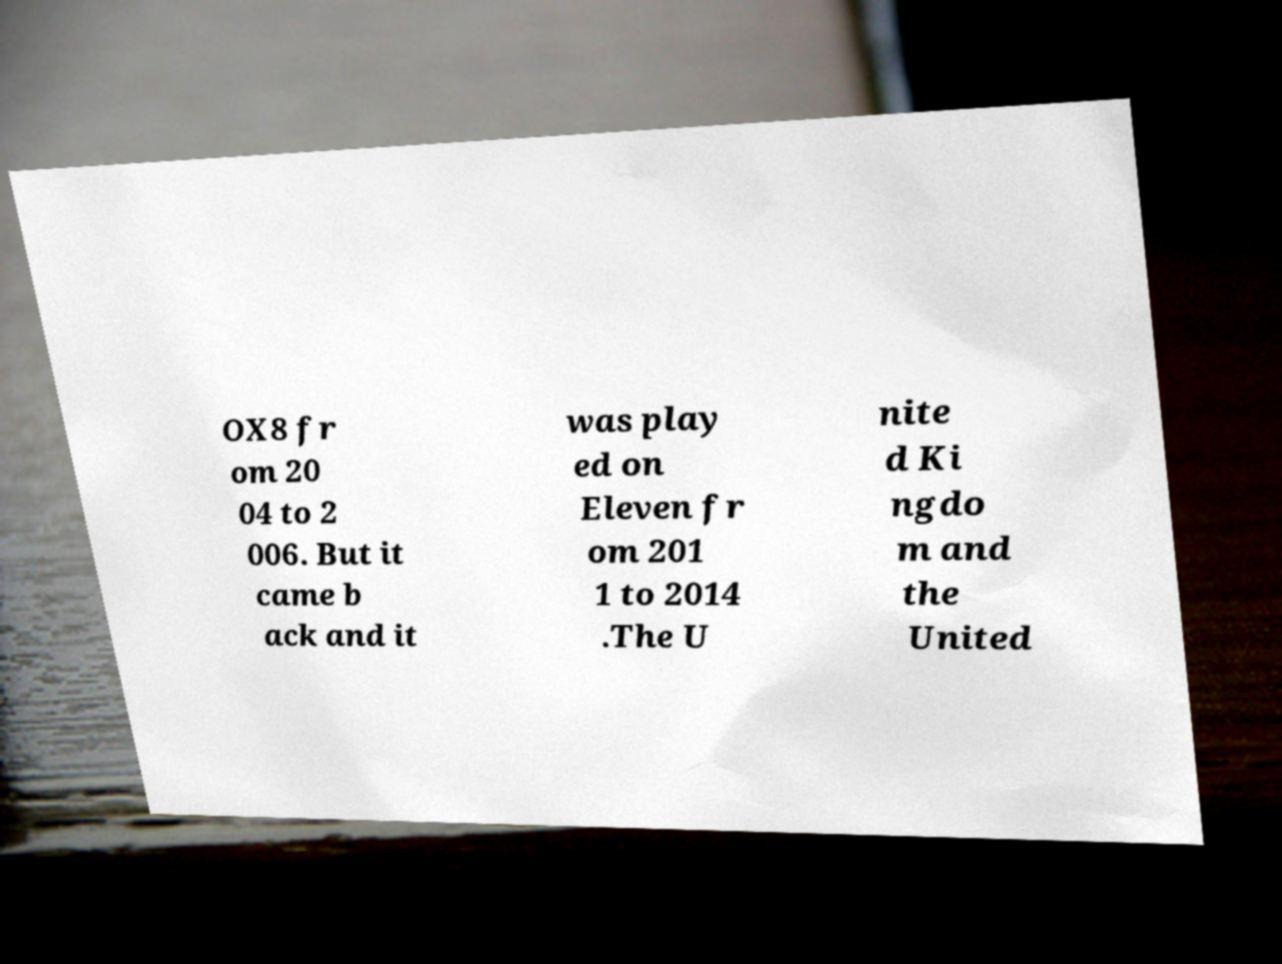Can you read and provide the text displayed in the image?This photo seems to have some interesting text. Can you extract and type it out for me? OX8 fr om 20 04 to 2 006. But it came b ack and it was play ed on Eleven fr om 201 1 to 2014 .The U nite d Ki ngdo m and the United 